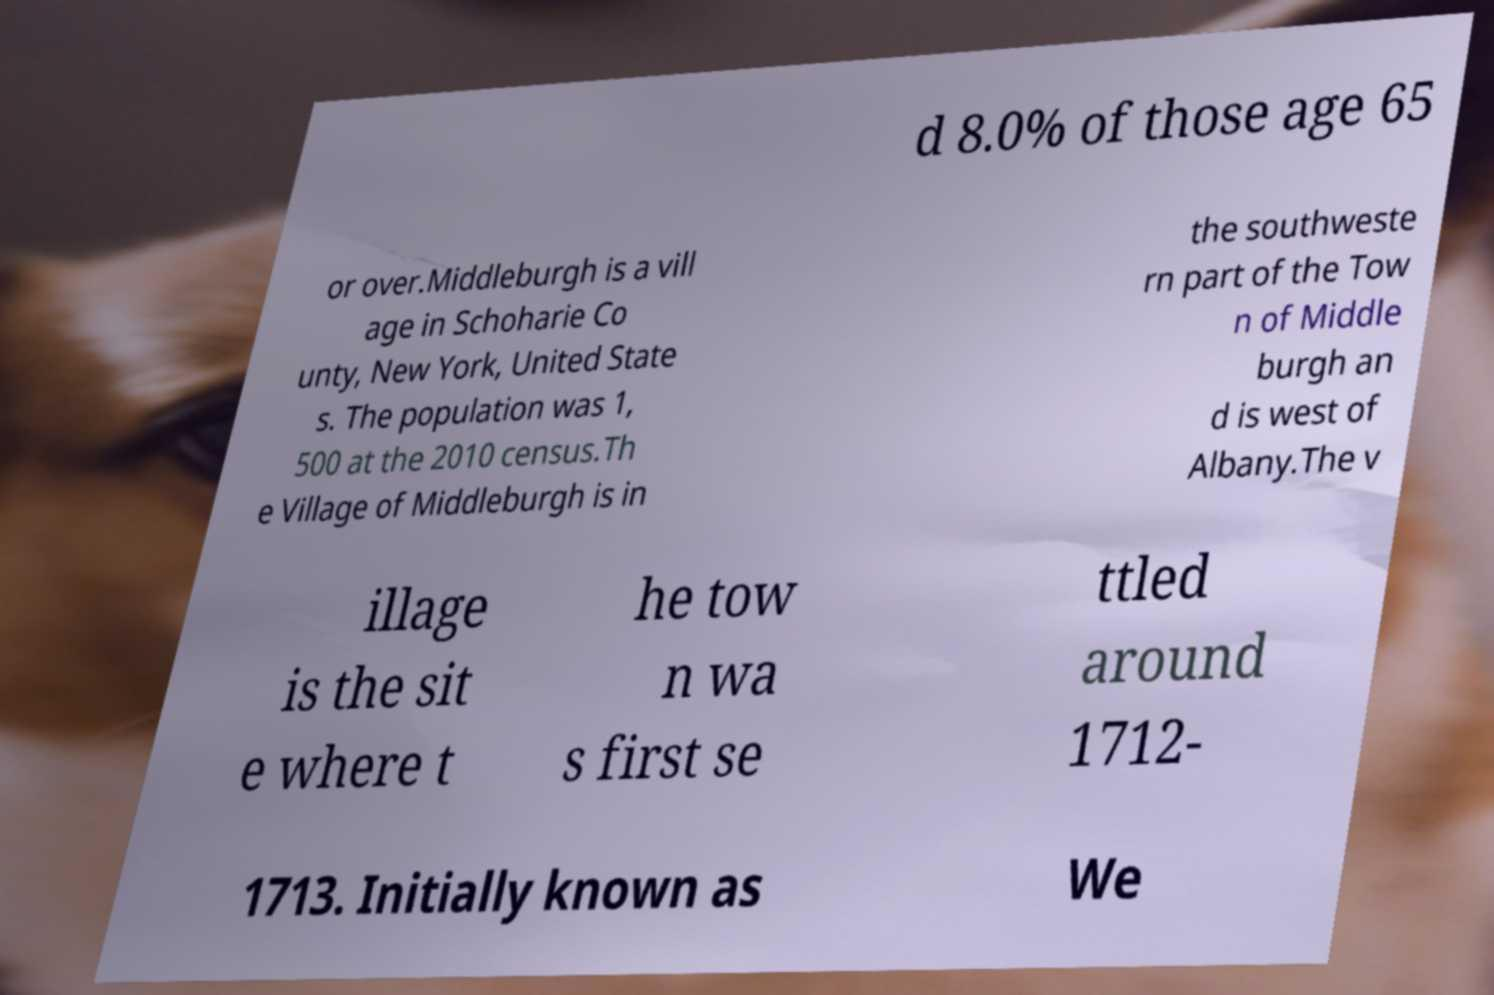Please identify and transcribe the text found in this image. d 8.0% of those age 65 or over.Middleburgh is a vill age in Schoharie Co unty, New York, United State s. The population was 1, 500 at the 2010 census.Th e Village of Middleburgh is in the southweste rn part of the Tow n of Middle burgh an d is west of Albany.The v illage is the sit e where t he tow n wa s first se ttled around 1712- 1713. Initially known as We 